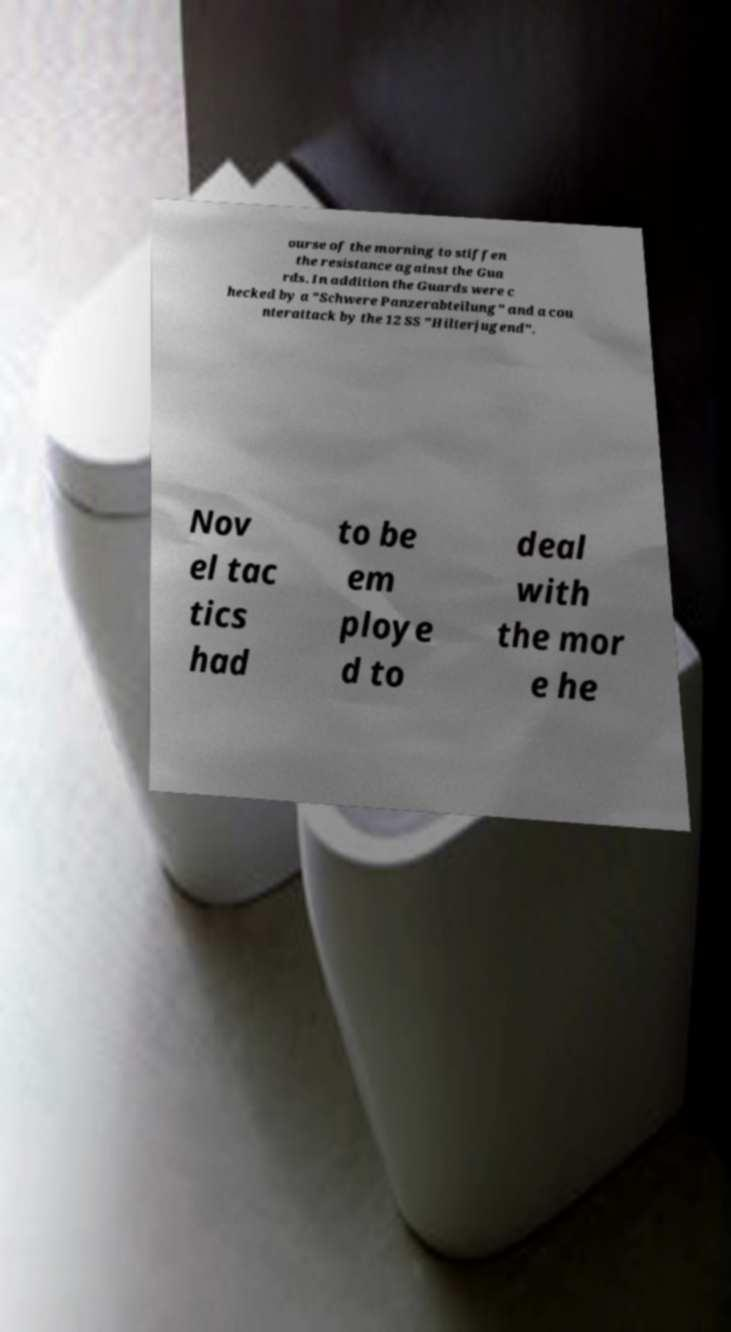What messages or text are displayed in this image? I need them in a readable, typed format. ourse of the morning to stiffen the resistance against the Gua rds. In addition the Guards were c hecked by a "Schwere Panzerabteilung" and a cou nterattack by the 12 SS "Hilterjugend". Nov el tac tics had to be em ploye d to deal with the mor e he 